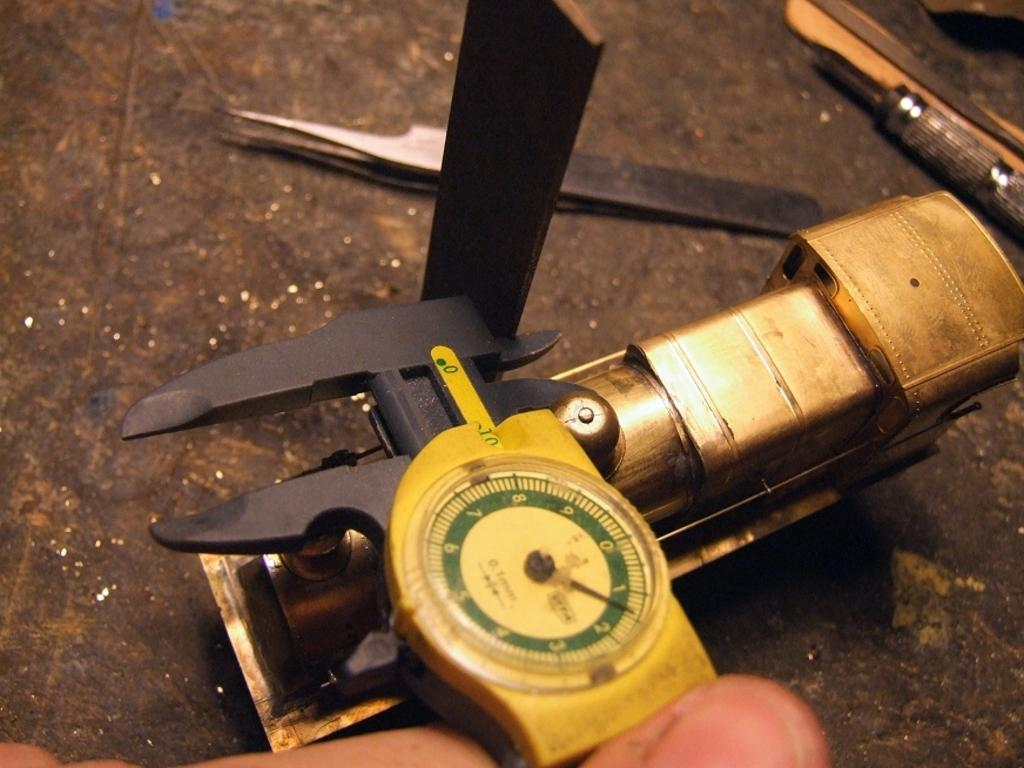What types of objects are visible in the image? There are many tools in the image. Can you describe the person's finger in the foreground of the image? Yes, there is a person's finger in the foreground of the image. What type of quartz is being used by the doctor in the image? There is no quartz or doctor present in the image; it only features tools and a person's finger. 